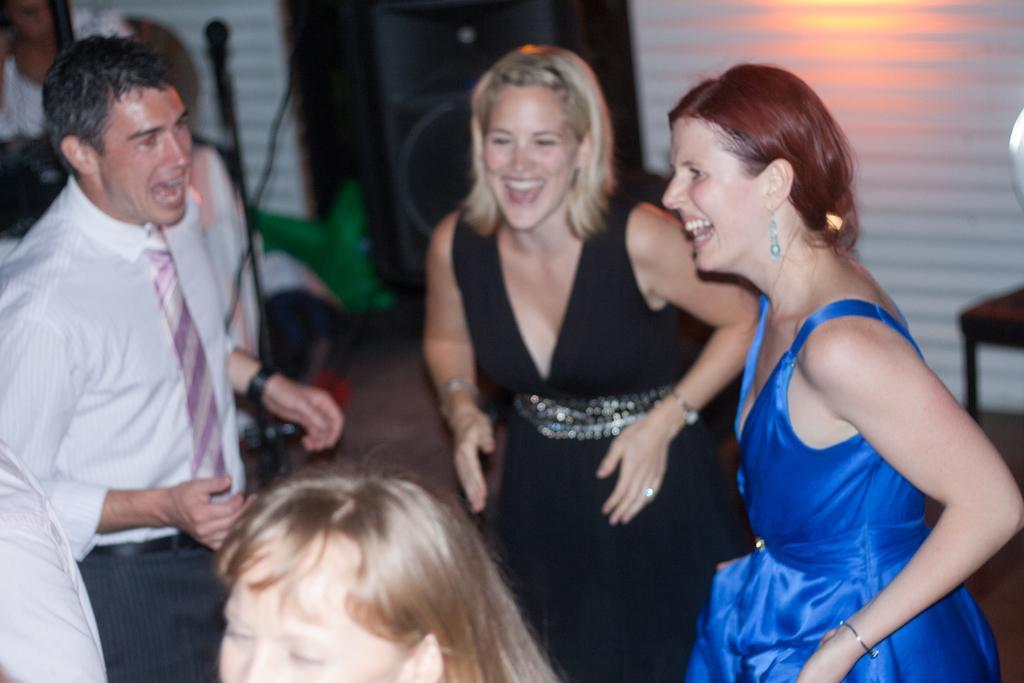Describe this image in one or two sentences. This image consists of few persons. It looks like they are dancing. On the right, we can see two women wearing a blue and a black color dresses. At the bottom, there is a floor. In the background, we can see a wall and a door. On the right, it looks like a table. 